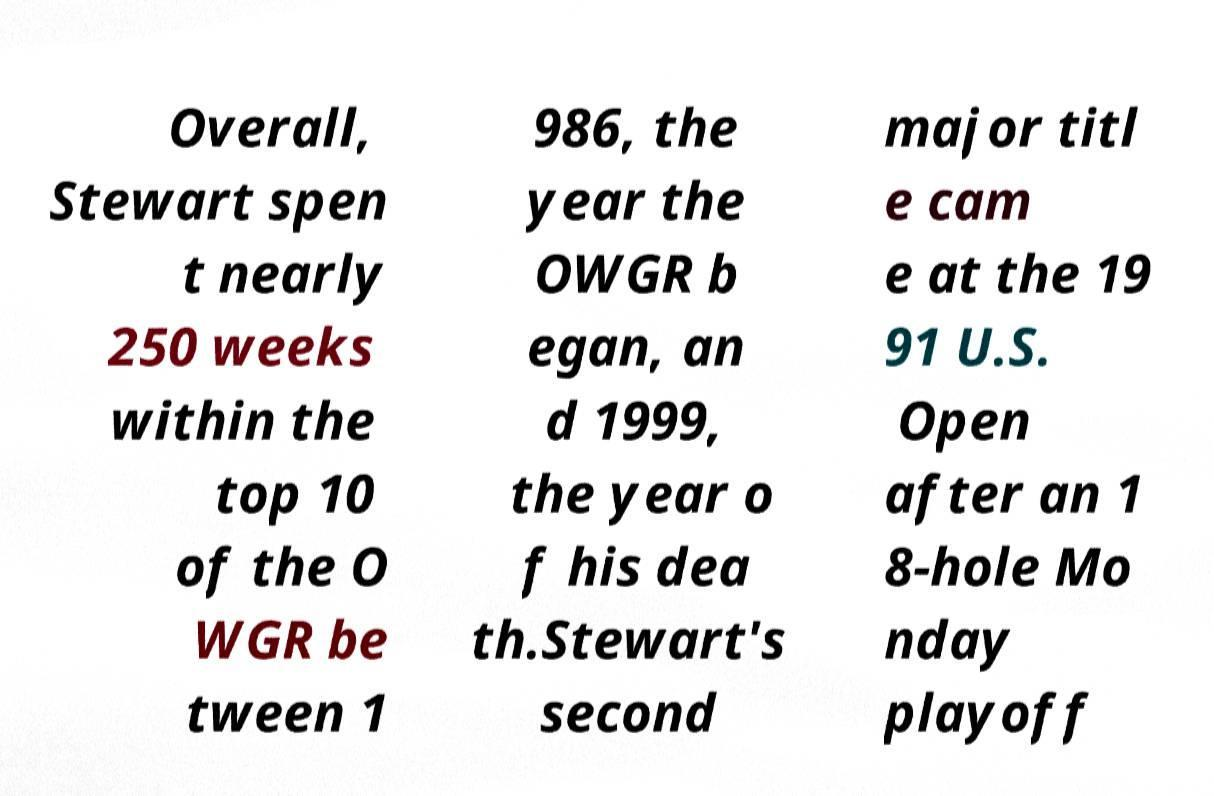For documentation purposes, I need the text within this image transcribed. Could you provide that? Overall, Stewart spen t nearly 250 weeks within the top 10 of the O WGR be tween 1 986, the year the OWGR b egan, an d 1999, the year o f his dea th.Stewart's second major titl e cam e at the 19 91 U.S. Open after an 1 8-hole Mo nday playoff 